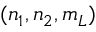Convert formula to latex. <formula><loc_0><loc_0><loc_500><loc_500>( n _ { 1 } , n _ { 2 } , m _ { L } )</formula> 